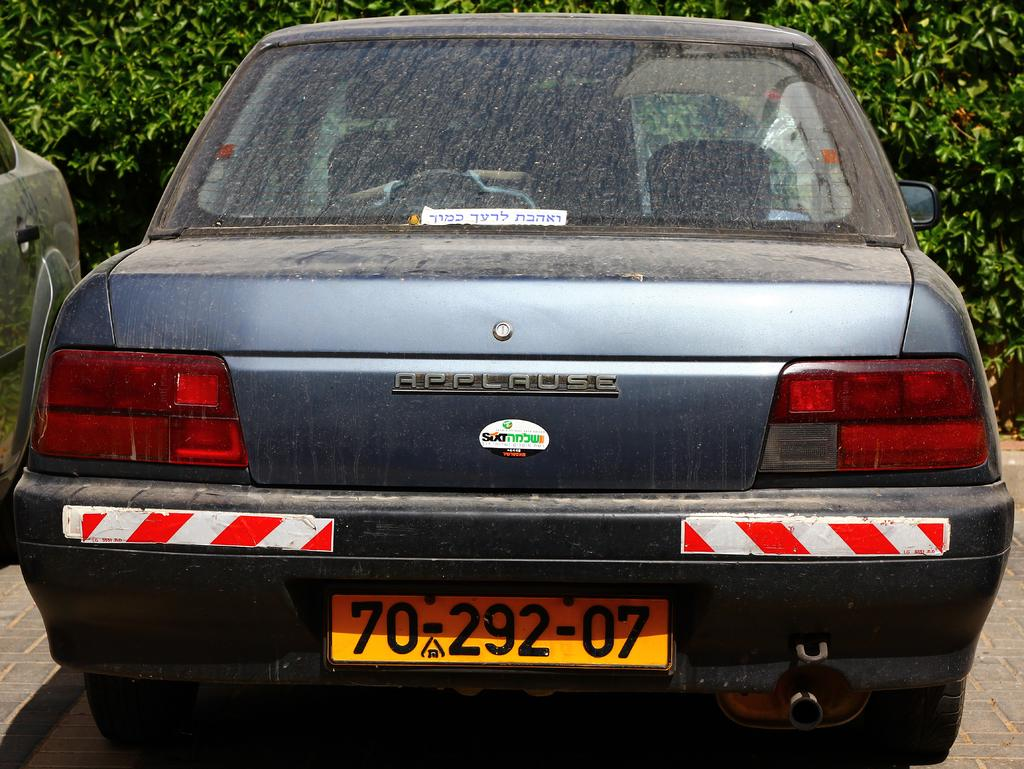<image>
Relay a brief, clear account of the picture shown. A yellow license plate on a blue car reads 70-292-07. 